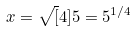<formula> <loc_0><loc_0><loc_500><loc_500>x = \sqrt { [ } 4 ] { 5 } = 5 ^ { 1 / 4 }</formula> 